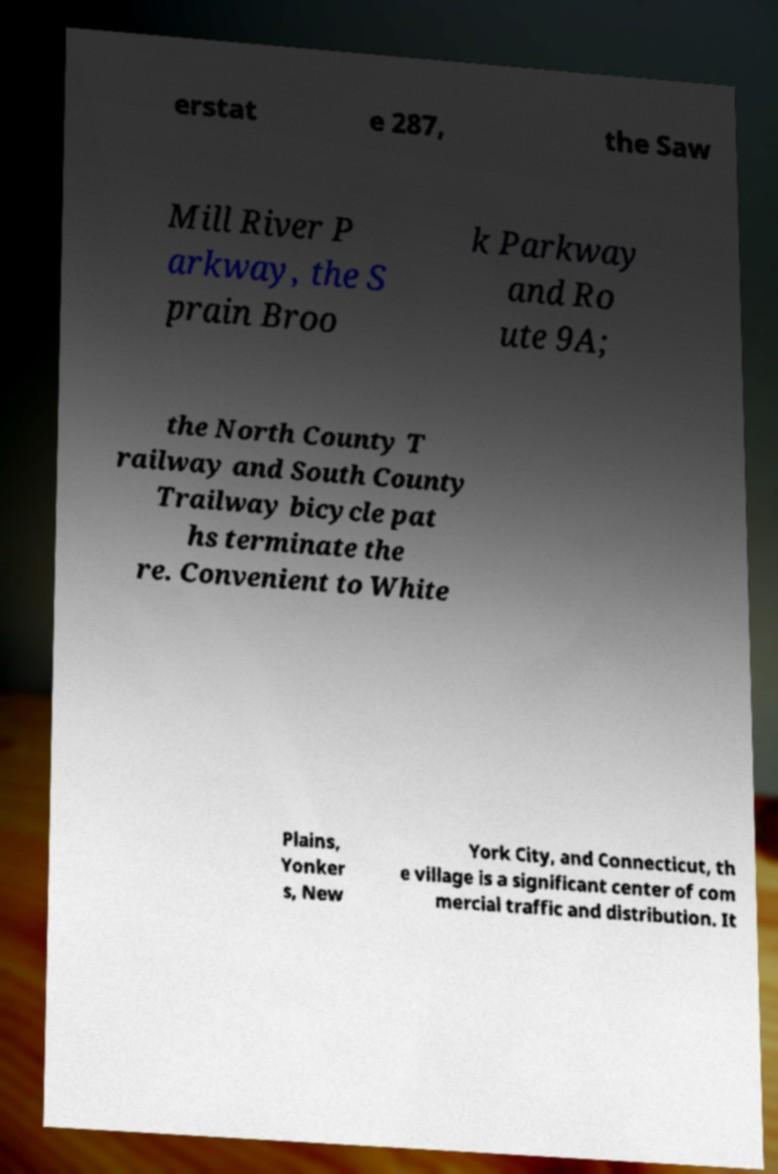What messages or text are displayed in this image? I need them in a readable, typed format. erstat e 287, the Saw Mill River P arkway, the S prain Broo k Parkway and Ro ute 9A; the North County T railway and South County Trailway bicycle pat hs terminate the re. Convenient to White Plains, Yonker s, New York City, and Connecticut, th e village is a significant center of com mercial traffic and distribution. It 